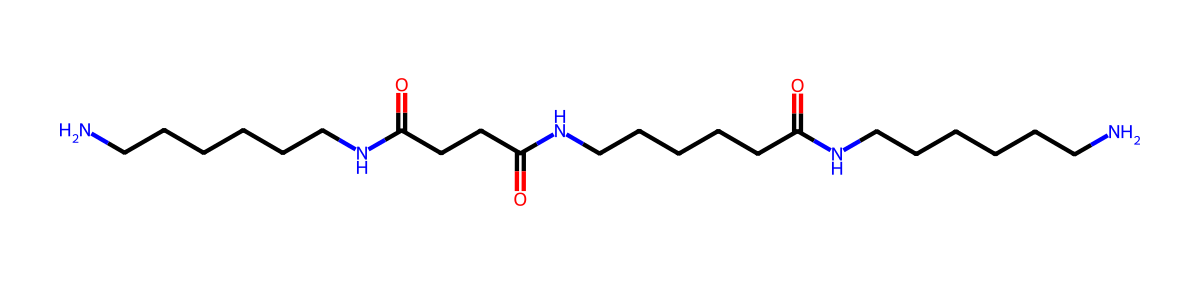What is the primary functional group present in this chemical? The chemical contains amide groups, which are characterized by the presence of nitrogen atoms bonded to carbonyl groups (C=O). The presence of these groups indicates it's a nylon.
Answer: amide How many nitrogen atoms are present in the structure? By examining the SMILES representation, there are three nitrogen atoms (N) that can be counted. Each represents a connection to an amide group.
Answer: three What type of polymer is represented by this chemical? The structure includes repeating units connected by amide bonds, indicating that it is a polyamide, which is a type of synthetic polymer used in fibers like nylon.
Answer: polyamide Which part of the chemical indicates that it is used for making fibers? The long carbon chain structure reflects the characteristic of polymers, and the presence of amide linkages supports its utility in fibers, providing durability and flexibility.
Answer: long carbon chain How many carbon atoms are in the structure? Counting the carbon atoms in the SMILES notation shows there are 18 carbon atoms (C). Each 'C' in the chain contributes to the overall molecular structure.
Answer: 18 What is the significance of the carbonyl groups in this chemical? The carbonyl groups (C=O) are crucial as they are part of the amide linkages that contribute to the packing and strength properties of nylon fibers.
Answer: packing and strength 